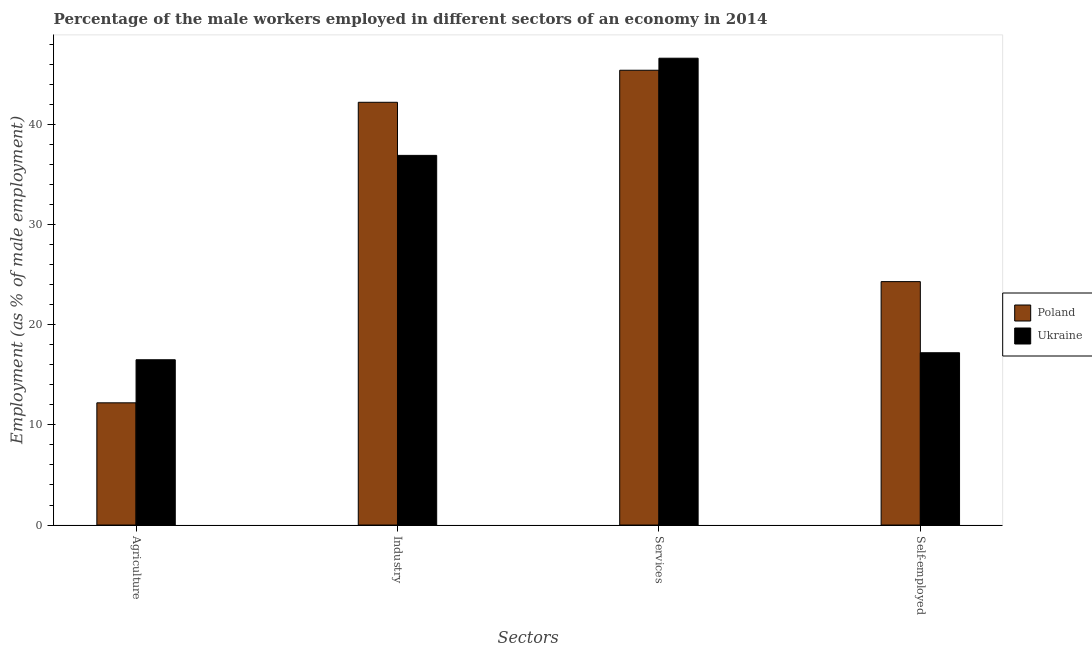Are the number of bars per tick equal to the number of legend labels?
Your response must be concise. Yes. What is the label of the 2nd group of bars from the left?
Offer a very short reply. Industry. What is the percentage of male workers in services in Ukraine?
Your response must be concise. 46.6. Across all countries, what is the maximum percentage of male workers in services?
Your response must be concise. 46.6. Across all countries, what is the minimum percentage of male workers in agriculture?
Offer a very short reply. 12.2. In which country was the percentage of male workers in industry maximum?
Ensure brevity in your answer.  Poland. In which country was the percentage of self employed male workers minimum?
Offer a very short reply. Ukraine. What is the total percentage of male workers in services in the graph?
Provide a succinct answer. 92. What is the difference between the percentage of male workers in industry in Poland and that in Ukraine?
Make the answer very short. 5.3. What is the difference between the percentage of male workers in agriculture in Ukraine and the percentage of male workers in services in Poland?
Your answer should be compact. -28.9. What is the average percentage of male workers in services per country?
Make the answer very short. 46. What is the difference between the percentage of male workers in services and percentage of male workers in industry in Ukraine?
Your answer should be compact. 9.7. What is the ratio of the percentage of male workers in services in Poland to that in Ukraine?
Your answer should be very brief. 0.97. Is the difference between the percentage of self employed male workers in Ukraine and Poland greater than the difference between the percentage of male workers in services in Ukraine and Poland?
Make the answer very short. No. What is the difference between the highest and the second highest percentage of male workers in industry?
Provide a succinct answer. 5.3. What is the difference between the highest and the lowest percentage of male workers in agriculture?
Provide a succinct answer. 4.3. In how many countries, is the percentage of male workers in services greater than the average percentage of male workers in services taken over all countries?
Keep it short and to the point. 1. Is the sum of the percentage of male workers in industry in Poland and Ukraine greater than the maximum percentage of male workers in services across all countries?
Make the answer very short. Yes. Is it the case that in every country, the sum of the percentage of male workers in services and percentage of male workers in agriculture is greater than the sum of percentage of self employed male workers and percentage of male workers in industry?
Your response must be concise. No. What does the 1st bar from the left in Agriculture represents?
Give a very brief answer. Poland. What does the 2nd bar from the right in Self-employed represents?
Provide a short and direct response. Poland. How many bars are there?
Ensure brevity in your answer.  8. Are all the bars in the graph horizontal?
Keep it short and to the point. No. Are the values on the major ticks of Y-axis written in scientific E-notation?
Your response must be concise. No. Where does the legend appear in the graph?
Offer a terse response. Center right. How many legend labels are there?
Make the answer very short. 2. What is the title of the graph?
Make the answer very short. Percentage of the male workers employed in different sectors of an economy in 2014. What is the label or title of the X-axis?
Your answer should be compact. Sectors. What is the label or title of the Y-axis?
Your response must be concise. Employment (as % of male employment). What is the Employment (as % of male employment) of Poland in Agriculture?
Offer a terse response. 12.2. What is the Employment (as % of male employment) of Ukraine in Agriculture?
Give a very brief answer. 16.5. What is the Employment (as % of male employment) in Poland in Industry?
Give a very brief answer. 42.2. What is the Employment (as % of male employment) of Ukraine in Industry?
Offer a terse response. 36.9. What is the Employment (as % of male employment) in Poland in Services?
Give a very brief answer. 45.4. What is the Employment (as % of male employment) of Ukraine in Services?
Offer a terse response. 46.6. What is the Employment (as % of male employment) in Poland in Self-employed?
Make the answer very short. 24.3. What is the Employment (as % of male employment) of Ukraine in Self-employed?
Ensure brevity in your answer.  17.2. Across all Sectors, what is the maximum Employment (as % of male employment) in Poland?
Offer a very short reply. 45.4. Across all Sectors, what is the maximum Employment (as % of male employment) in Ukraine?
Keep it short and to the point. 46.6. Across all Sectors, what is the minimum Employment (as % of male employment) in Poland?
Keep it short and to the point. 12.2. What is the total Employment (as % of male employment) of Poland in the graph?
Keep it short and to the point. 124.1. What is the total Employment (as % of male employment) in Ukraine in the graph?
Your answer should be compact. 117.2. What is the difference between the Employment (as % of male employment) of Ukraine in Agriculture and that in Industry?
Ensure brevity in your answer.  -20.4. What is the difference between the Employment (as % of male employment) of Poland in Agriculture and that in Services?
Ensure brevity in your answer.  -33.2. What is the difference between the Employment (as % of male employment) in Ukraine in Agriculture and that in Services?
Offer a terse response. -30.1. What is the difference between the Employment (as % of male employment) of Ukraine in Agriculture and that in Self-employed?
Offer a very short reply. -0.7. What is the difference between the Employment (as % of male employment) in Poland in Industry and that in Services?
Provide a succinct answer. -3.2. What is the difference between the Employment (as % of male employment) in Poland in Industry and that in Self-employed?
Your answer should be compact. 17.9. What is the difference between the Employment (as % of male employment) of Poland in Services and that in Self-employed?
Your answer should be very brief. 21.1. What is the difference between the Employment (as % of male employment) of Ukraine in Services and that in Self-employed?
Provide a short and direct response. 29.4. What is the difference between the Employment (as % of male employment) of Poland in Agriculture and the Employment (as % of male employment) of Ukraine in Industry?
Give a very brief answer. -24.7. What is the difference between the Employment (as % of male employment) in Poland in Agriculture and the Employment (as % of male employment) in Ukraine in Services?
Your answer should be very brief. -34.4. What is the difference between the Employment (as % of male employment) of Poland in Agriculture and the Employment (as % of male employment) of Ukraine in Self-employed?
Offer a very short reply. -5. What is the difference between the Employment (as % of male employment) in Poland in Industry and the Employment (as % of male employment) in Ukraine in Services?
Keep it short and to the point. -4.4. What is the difference between the Employment (as % of male employment) of Poland in Services and the Employment (as % of male employment) of Ukraine in Self-employed?
Your response must be concise. 28.2. What is the average Employment (as % of male employment) in Poland per Sectors?
Offer a terse response. 31.02. What is the average Employment (as % of male employment) in Ukraine per Sectors?
Offer a terse response. 29.3. What is the difference between the Employment (as % of male employment) of Poland and Employment (as % of male employment) of Ukraine in Industry?
Your answer should be compact. 5.3. What is the difference between the Employment (as % of male employment) of Poland and Employment (as % of male employment) of Ukraine in Services?
Give a very brief answer. -1.2. What is the ratio of the Employment (as % of male employment) in Poland in Agriculture to that in Industry?
Your answer should be compact. 0.29. What is the ratio of the Employment (as % of male employment) in Ukraine in Agriculture to that in Industry?
Ensure brevity in your answer.  0.45. What is the ratio of the Employment (as % of male employment) in Poland in Agriculture to that in Services?
Provide a succinct answer. 0.27. What is the ratio of the Employment (as % of male employment) of Ukraine in Agriculture to that in Services?
Keep it short and to the point. 0.35. What is the ratio of the Employment (as % of male employment) of Poland in Agriculture to that in Self-employed?
Provide a short and direct response. 0.5. What is the ratio of the Employment (as % of male employment) of Ukraine in Agriculture to that in Self-employed?
Keep it short and to the point. 0.96. What is the ratio of the Employment (as % of male employment) in Poland in Industry to that in Services?
Your answer should be very brief. 0.93. What is the ratio of the Employment (as % of male employment) in Ukraine in Industry to that in Services?
Provide a succinct answer. 0.79. What is the ratio of the Employment (as % of male employment) of Poland in Industry to that in Self-employed?
Ensure brevity in your answer.  1.74. What is the ratio of the Employment (as % of male employment) in Ukraine in Industry to that in Self-employed?
Offer a very short reply. 2.15. What is the ratio of the Employment (as % of male employment) in Poland in Services to that in Self-employed?
Your response must be concise. 1.87. What is the ratio of the Employment (as % of male employment) of Ukraine in Services to that in Self-employed?
Offer a very short reply. 2.71. What is the difference between the highest and the second highest Employment (as % of male employment) in Ukraine?
Provide a succinct answer. 9.7. What is the difference between the highest and the lowest Employment (as % of male employment) of Poland?
Your answer should be very brief. 33.2. What is the difference between the highest and the lowest Employment (as % of male employment) of Ukraine?
Make the answer very short. 30.1. 